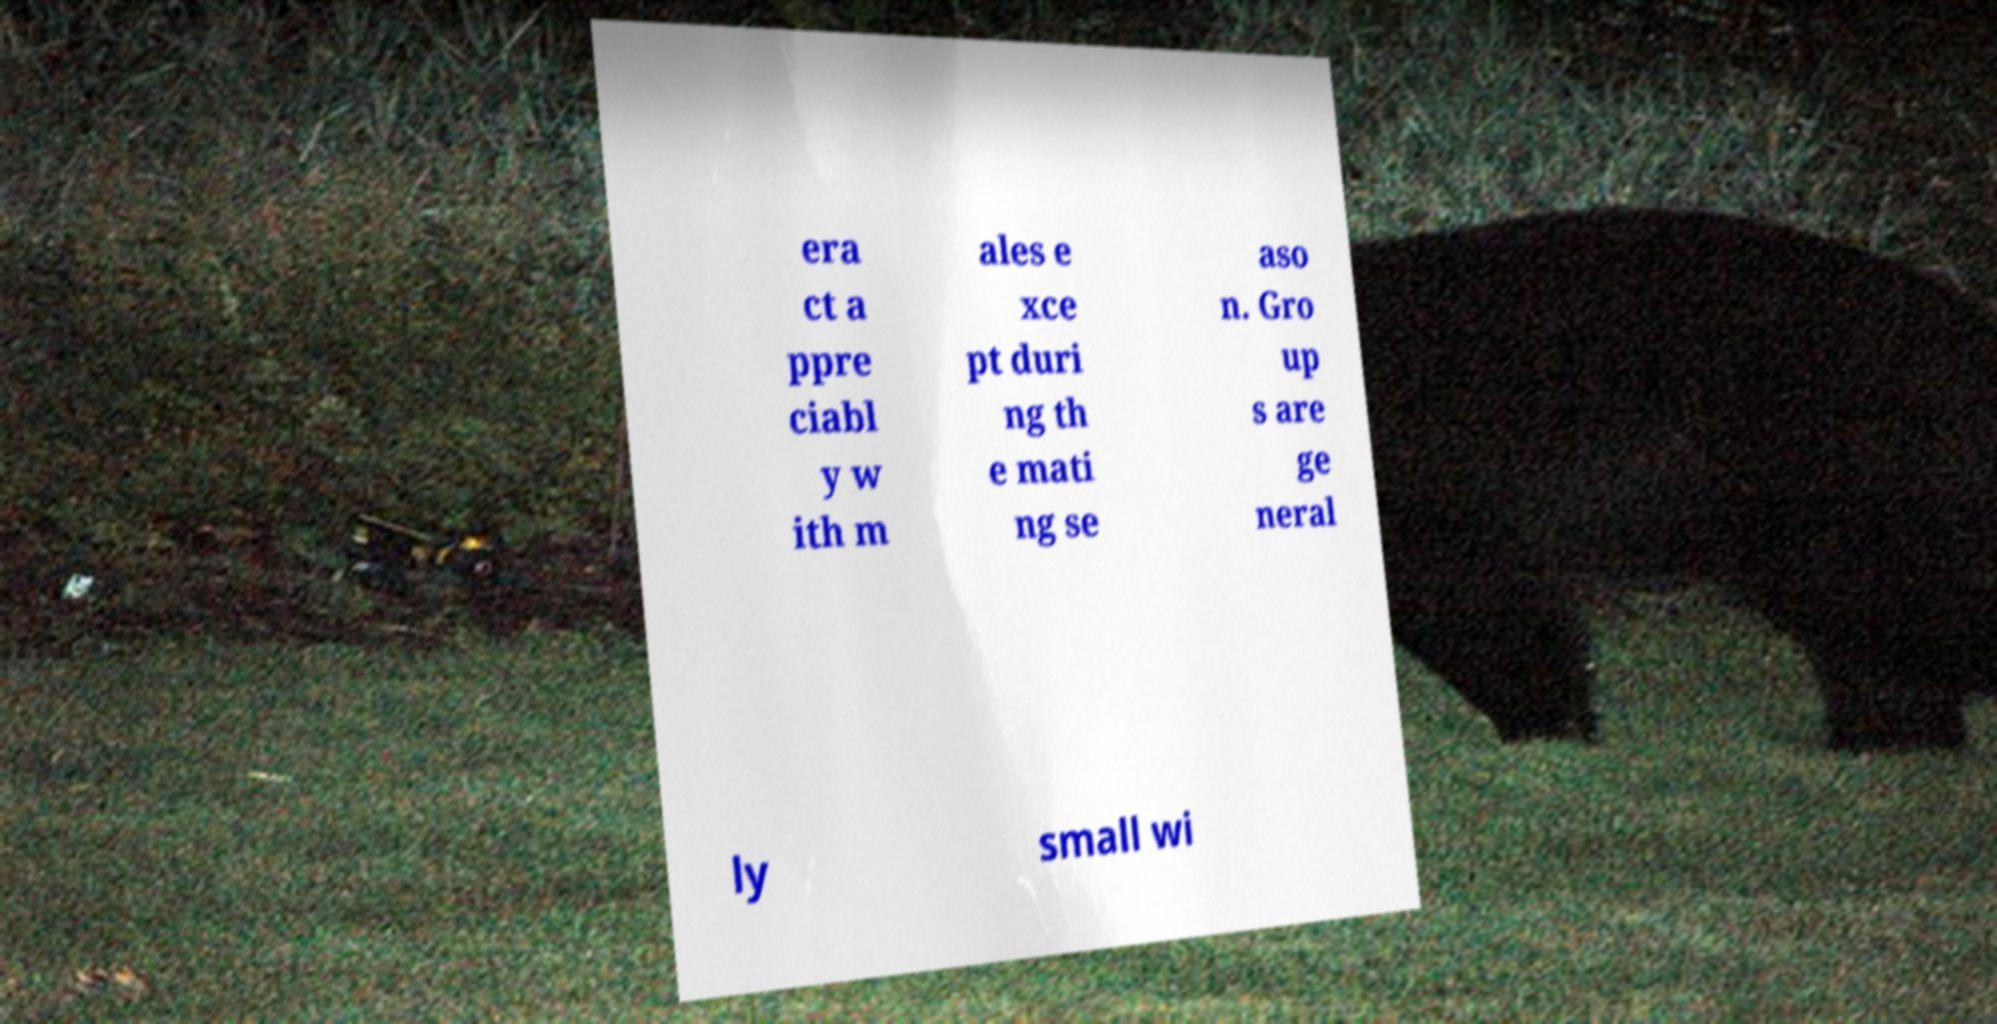Could you assist in decoding the text presented in this image and type it out clearly? era ct a ppre ciabl y w ith m ales e xce pt duri ng th e mati ng se aso n. Gro up s are ge neral ly small wi 